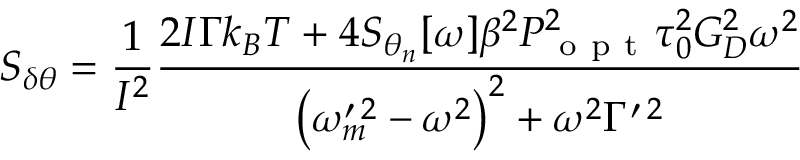Convert formula to latex. <formula><loc_0><loc_0><loc_500><loc_500>S _ { \delta \theta } = \frac { 1 } { I ^ { 2 } } \frac { 2 I \Gamma k _ { B } T + 4 S _ { \theta _ { n } } [ \omega ] \beta ^ { 2 } P _ { o p t } ^ { 2 } \tau _ { 0 } ^ { 2 } G _ { D } ^ { 2 } \omega ^ { 2 } } { \left ( \omega _ { m } ^ { \prime \, 2 } - \omega ^ { 2 } \right ) ^ { 2 } + \omega ^ { 2 } \Gamma ^ { \prime \, 2 } }</formula> 